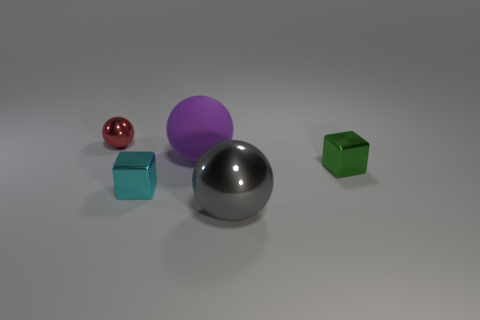How many other things are there of the same size as the purple rubber thing?
Your response must be concise. 1. What color is the small object to the right of the large thing in front of the big sphere left of the gray ball?
Ensure brevity in your answer.  Green. What is the shape of the thing that is right of the cyan object and behind the green metal block?
Provide a short and direct response. Sphere. How many other objects are there of the same shape as the tiny cyan thing?
Make the answer very short. 1. The metal thing behind the object that is right of the metallic ball that is in front of the small red ball is what shape?
Keep it short and to the point. Sphere. How many objects are green shiny things or spheres in front of the green object?
Provide a succinct answer. 2. Does the small metallic object to the right of the large rubber thing have the same shape as the metallic thing behind the large purple thing?
Offer a very short reply. No. What number of objects are large red shiny spheres or blocks?
Your answer should be very brief. 2. Is there anything else that has the same material as the purple object?
Your response must be concise. No. Are any red things visible?
Offer a very short reply. Yes. 